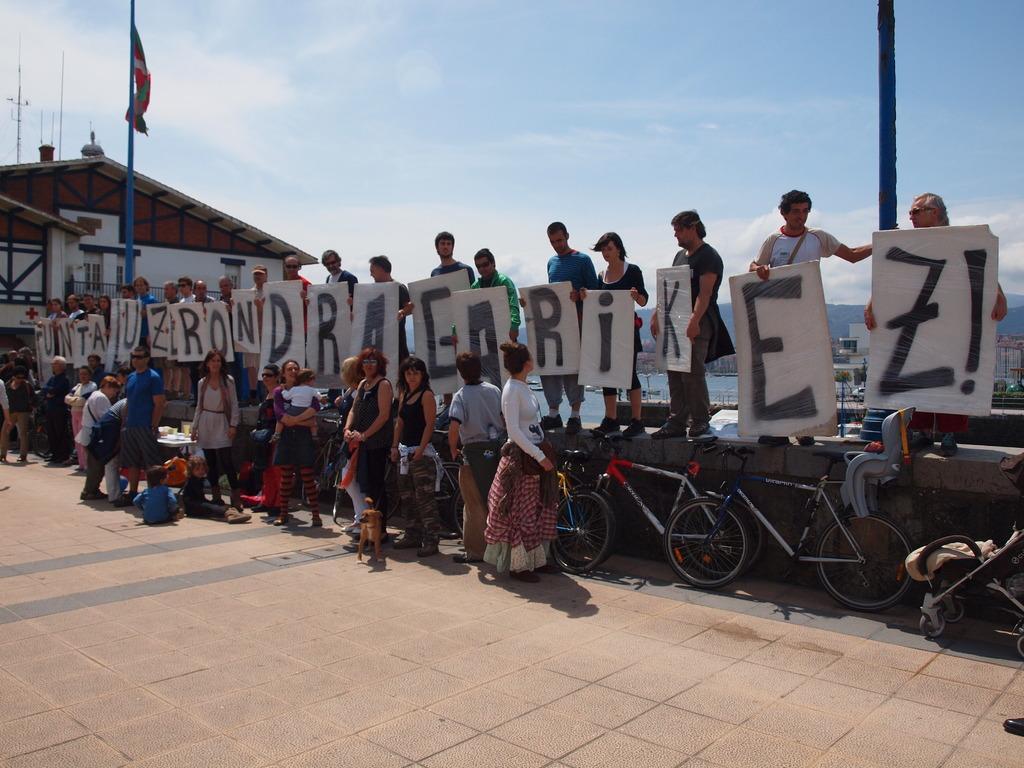How would you summarize this image in a sentence or two? In this image I can see group of people standing and holding few boards. Background I can see the flag in red, white and green color and I can also see the building and the sky is in white and blue color. 